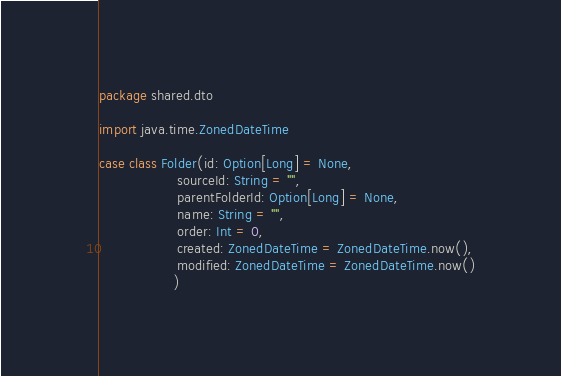Convert code to text. <code><loc_0><loc_0><loc_500><loc_500><_Scala_>package shared.dto

import java.time.ZonedDateTime

case class Folder(id: Option[Long] = None,
                  sourceId: String = "",
                  parentFolderId: Option[Long] = None,
                  name: String = "",
                  order: Int = 0,
                  created: ZonedDateTime = ZonedDateTime.now(),
                  modified: ZonedDateTime = ZonedDateTime.now()
                 )</code> 